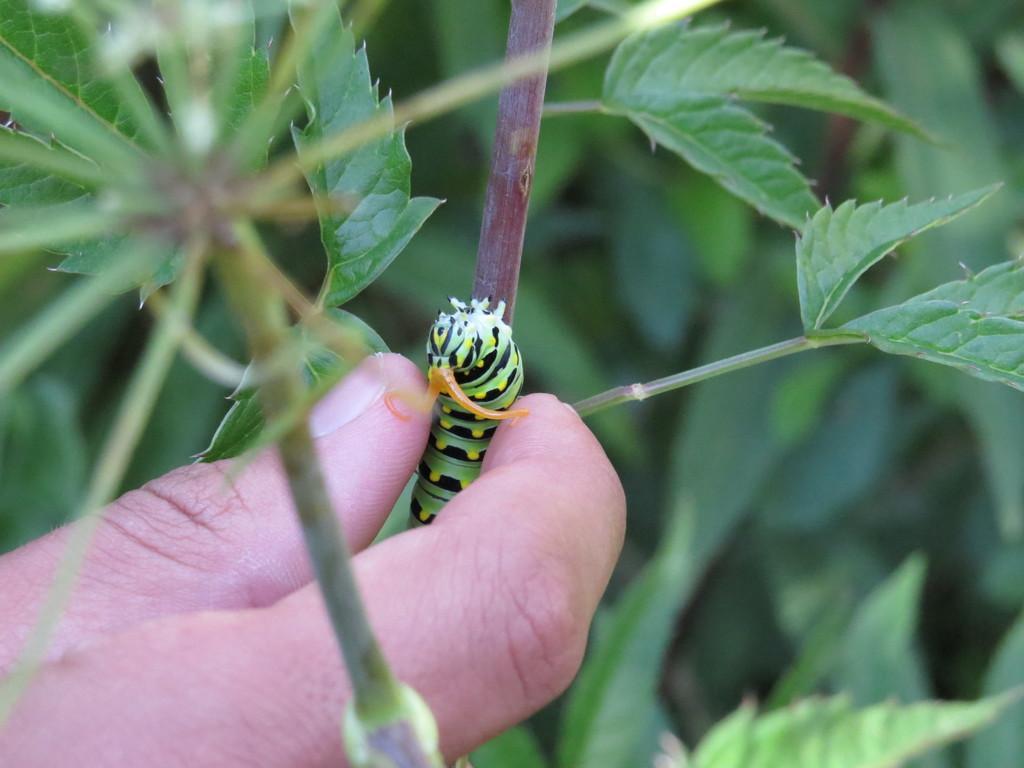Can you describe this image briefly? In the foreground of this image, there is a person´s hand holding an insect which is on a plant and the background is greenery. 